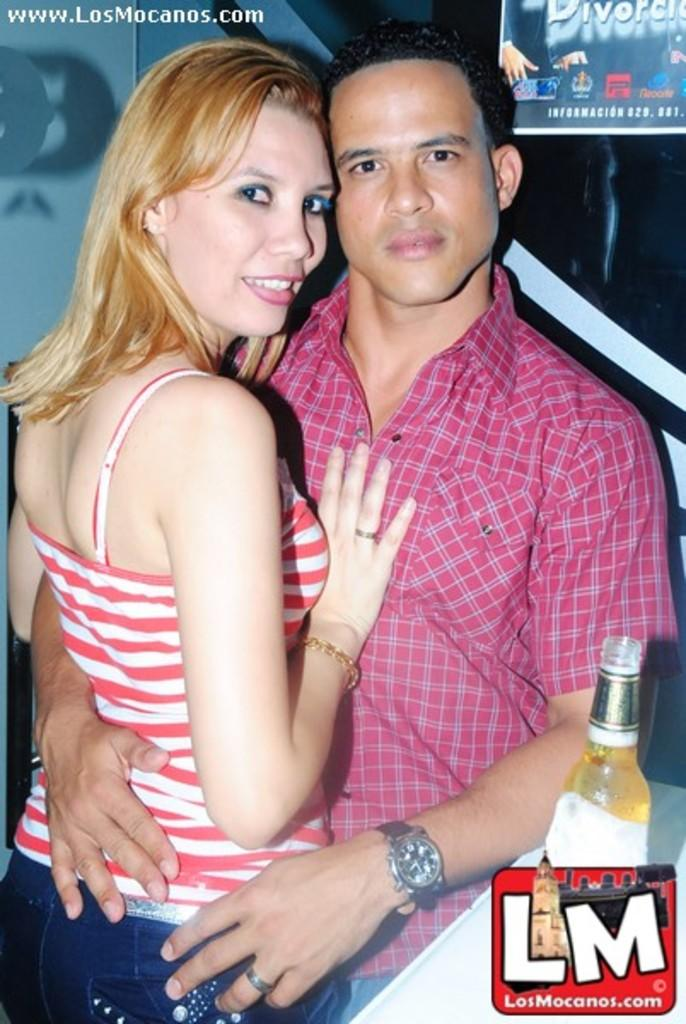How many people are present in the image? There are two people standing in the image. What is located in front of the people? There is a bottle in front of the people. What can be seen at the back of the people? There is a banner at the back of the people. What type of fruit is hanging from the banner in the image? There is no fruit present in the image, and therefore no fruit can be seen hanging from the banner. 